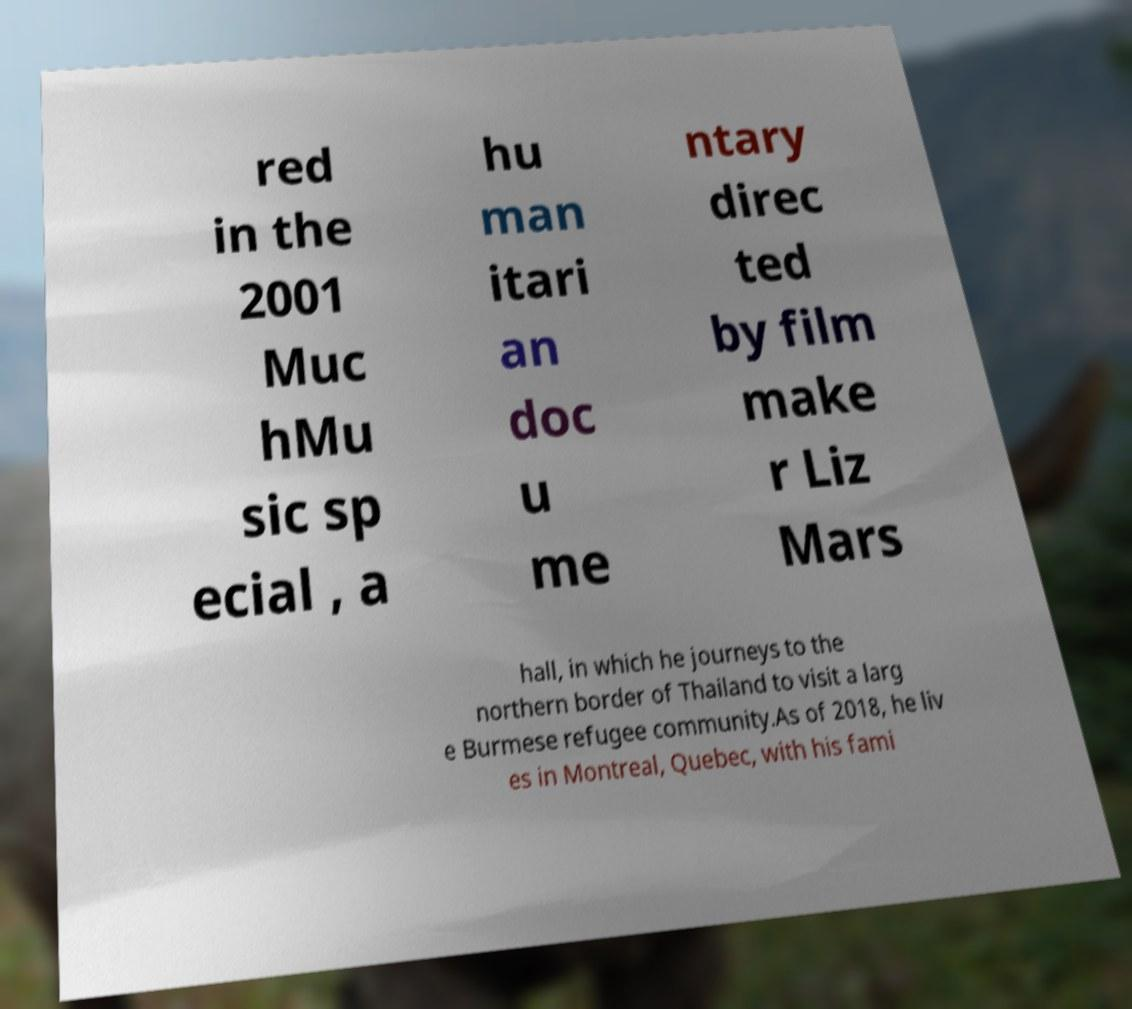Please identify and transcribe the text found in this image. red in the 2001 Muc hMu sic sp ecial , a hu man itari an doc u me ntary direc ted by film make r Liz Mars hall, in which he journeys to the northern border of Thailand to visit a larg e Burmese refugee community.As of 2018, he liv es in Montreal, Quebec, with his fami 